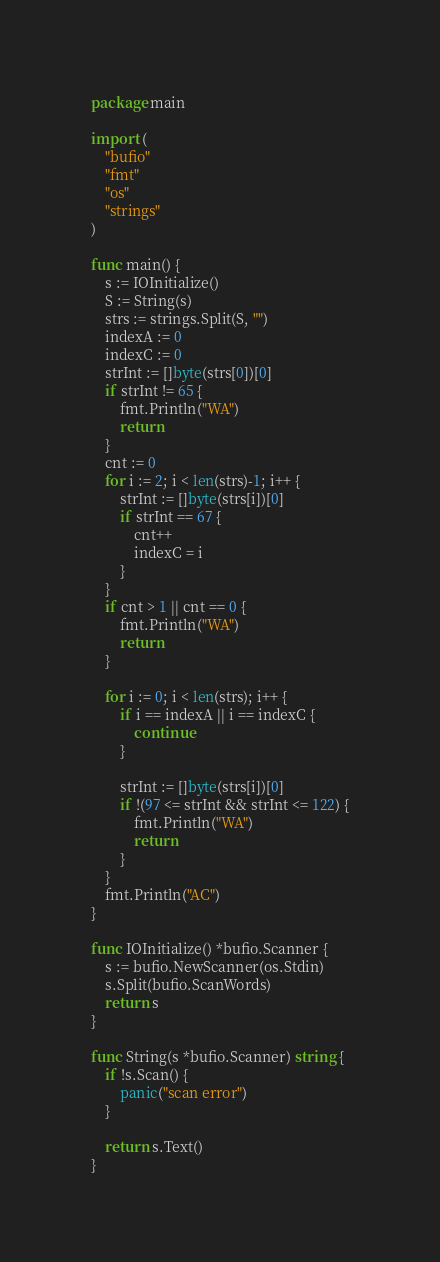<code> <loc_0><loc_0><loc_500><loc_500><_Go_>package main

import (
	"bufio"
	"fmt"
	"os"
	"strings"
)

func main() {
	s := IOInitialize()
	S := String(s)
	strs := strings.Split(S, "")
	indexA := 0
	indexC := 0
	strInt := []byte(strs[0])[0]
	if strInt != 65 {
		fmt.Println("WA")
		return
	}
	cnt := 0
	for i := 2; i < len(strs)-1; i++ {
		strInt := []byte(strs[i])[0]
		if strInt == 67 {
			cnt++
			indexC = i
		}
	}
	if cnt > 1 || cnt == 0 {
		fmt.Println("WA")
		return
	}

	for i := 0; i < len(strs); i++ {
		if i == indexA || i == indexC {
			continue
		}

		strInt := []byte(strs[i])[0]
		if !(97 <= strInt && strInt <= 122) {
			fmt.Println("WA")
			return
		}
	}
	fmt.Println("AC")
}

func IOInitialize() *bufio.Scanner {
	s := bufio.NewScanner(os.Stdin)
	s.Split(bufio.ScanWords)
	return s
}

func String(s *bufio.Scanner) string {
	if !s.Scan() {
		panic("scan error")
	}

	return s.Text()
}
</code> 